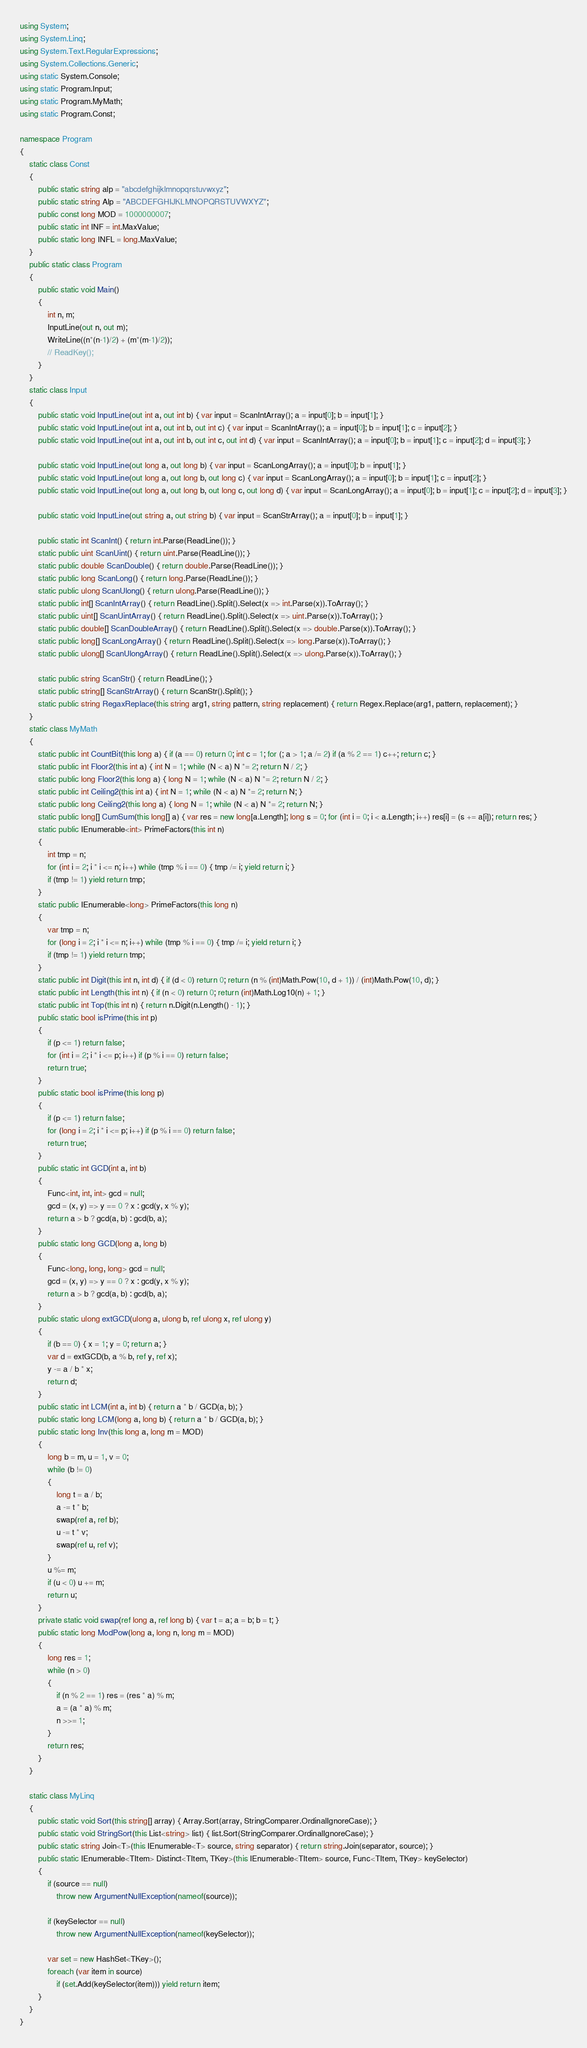Convert code to text. <code><loc_0><loc_0><loc_500><loc_500><_C#_>using System;
using System.Linq;
using System.Text.RegularExpressions;
using System.Collections.Generic;
using static System.Console;
using static Program.Input;
using static Program.MyMath;
using static Program.Const;

namespace Program
{
    static class Const
    {
        public static string alp = "abcdefghijklmnopqrstuvwxyz";
        public static string Alp = "ABCDEFGHIJKLMNOPQRSTUVWXYZ";
        public const long MOD = 1000000007;
        public static int INF = int.MaxValue;
        public static long INFL = long.MaxValue;
    }
    public static class Program
    {
        public static void Main()
        {
            int n, m;
            InputLine(out n, out m);
            WriteLine((n*(n-1)/2) + (m*(m-1)/2));
            // ReadKey();
        }
    }
    static class Input
    {
        public static void InputLine(out int a, out int b) { var input = ScanIntArray(); a = input[0]; b = input[1]; }
        public static void InputLine(out int a, out int b, out int c) { var input = ScanIntArray(); a = input[0]; b = input[1]; c = input[2]; }
        public static void InputLine(out int a, out int b, out int c, out int d) { var input = ScanIntArray(); a = input[0]; b = input[1]; c = input[2]; d = input[3]; }

        public static void InputLine(out long a, out long b) { var input = ScanLongArray(); a = input[0]; b = input[1]; }
        public static void InputLine(out long a, out long b, out long c) { var input = ScanLongArray(); a = input[0]; b = input[1]; c = input[2]; }
        public static void InputLine(out long a, out long b, out long c, out long d) { var input = ScanLongArray(); a = input[0]; b = input[1]; c = input[2]; d = input[3]; }

        public static void InputLine(out string a, out string b) { var input = ScanStrArray(); a = input[0]; b = input[1]; }

        public static int ScanInt() { return int.Parse(ReadLine()); }
        static public uint ScanUint() { return uint.Parse(ReadLine()); }
        static public double ScanDouble() { return double.Parse(ReadLine()); }
        static public long ScanLong() { return long.Parse(ReadLine()); }
        static public ulong ScanUlong() { return ulong.Parse(ReadLine()); }
        static public int[] ScanIntArray() { return ReadLine().Split().Select(x => int.Parse(x)).ToArray(); }
        static public uint[] ScanUintArray() { return ReadLine().Split().Select(x => uint.Parse(x)).ToArray(); }
        static public double[] ScanDoubleArray() { return ReadLine().Split().Select(x => double.Parse(x)).ToArray(); }
        static public long[] ScanLongArray() { return ReadLine().Split().Select(x => long.Parse(x)).ToArray(); }
        static public ulong[] ScanUlongArray() { return ReadLine().Split().Select(x => ulong.Parse(x)).ToArray(); }

        static public string ScanStr() { return ReadLine(); }
        static public string[] ScanStrArray() { return ScanStr().Split(); }
        static public string RegaxReplace(this string arg1, string pattern, string replacement) { return Regex.Replace(arg1, pattern, replacement); }
    }
    static class MyMath
    {
        static public int CountBit(this long a) { if (a == 0) return 0; int c = 1; for (; a > 1; a /= 2) if (a % 2 == 1) c++; return c; }
        static public int Floor2(this int a) { int N = 1; while (N < a) N *= 2; return N / 2; }
        static public long Floor2(this long a) { long N = 1; while (N < a) N *= 2; return N / 2; }
        static public int Ceiling2(this int a) { int N = 1; while (N < a) N *= 2; return N; }
        static public long Ceiling2(this long a) { long N = 1; while (N < a) N *= 2; return N; }
        static public long[] CumSum(this long[] a) { var res = new long[a.Length]; long s = 0; for (int i = 0; i < a.Length; i++) res[i] = (s += a[i]); return res; }
        static public IEnumerable<int> PrimeFactors(this int n)
        {
            int tmp = n;
            for (int i = 2; i * i <= n; i++) while (tmp % i == 0) { tmp /= i; yield return i; }
            if (tmp != 1) yield return tmp;
        }
        static public IEnumerable<long> PrimeFactors(this long n)
        {
            var tmp = n;
            for (long i = 2; i * i <= n; i++) while (tmp % i == 0) { tmp /= i; yield return i; }
            if (tmp != 1) yield return tmp;
        }
        static public int Digit(this int n, int d) { if (d < 0) return 0; return (n % (int)Math.Pow(10, d + 1)) / (int)Math.Pow(10, d); }
        static public int Length(this int n) { if (n < 0) return 0; return (int)Math.Log10(n) + 1; }
        static public int Top(this int n) { return n.Digit(n.Length() - 1); }
        public static bool isPrime(this int p)
        {
            if (p <= 1) return false;
            for (int i = 2; i * i <= p; i++) if (p % i == 0) return false;
            return true;
        }
        public static bool isPrime(this long p)
        {
            if (p <= 1) return false;
            for (long i = 2; i * i <= p; i++) if (p % i == 0) return false;
            return true;
        }
        public static int GCD(int a, int b)
        {
            Func<int, int, int> gcd = null;
            gcd = (x, y) => y == 0 ? x : gcd(y, x % y);
            return a > b ? gcd(a, b) : gcd(b, a);
        }
        public static long GCD(long a, long b)
        {
            Func<long, long, long> gcd = null;
            gcd = (x, y) => y == 0 ? x : gcd(y, x % y);
            return a > b ? gcd(a, b) : gcd(b, a);
        }
        public static ulong extGCD(ulong a, ulong b, ref ulong x, ref ulong y)
        {
            if (b == 0) { x = 1; y = 0; return a; }
            var d = extGCD(b, a % b, ref y, ref x);
            y -= a / b * x;
            return d;
        }
        public static int LCM(int a, int b) { return a * b / GCD(a, b); }
        public static long LCM(long a, long b) { return a * b / GCD(a, b); }
        public static long Inv(this long a, long m = MOD)
        {
            long b = m, u = 1, v = 0;
            while (b != 0)
            {
                long t = a / b;
                a -= t * b;
                swap(ref a, ref b);
                u -= t * v;
                swap(ref u, ref v);
            }
            u %= m;
            if (u < 0) u += m;
            return u;
        }
        private static void swap(ref long a, ref long b) { var t = a; a = b; b = t; }
        public static long ModPow(long a, long n, long m = MOD)
        {
            long res = 1;
            while (n > 0)
            {
                if (n % 2 == 1) res = (res * a) % m;
                a = (a * a) % m;
                n >>= 1;
            }
            return res;
        }
    }

    static class MyLinq
    {
        public static void Sort(this string[] array) { Array.Sort(array, StringComparer.OrdinalIgnoreCase); }
        public static void StringSort(this List<string> list) { list.Sort(StringComparer.OrdinalIgnoreCase); }
        public static string Join<T>(this IEnumerable<T> source, string separator) { return string.Join(separator, source); }
        public static IEnumerable<TItem> Distinct<TItem, TKey>(this IEnumerable<TItem> source, Func<TItem, TKey> keySelector)
        {
            if (source == null)
                throw new ArgumentNullException(nameof(source));

            if (keySelector == null)
                throw new ArgumentNullException(nameof(keySelector));

            var set = new HashSet<TKey>();
            foreach (var item in source)
                if (set.Add(keySelector(item))) yield return item;
        }
    }
}
</code> 